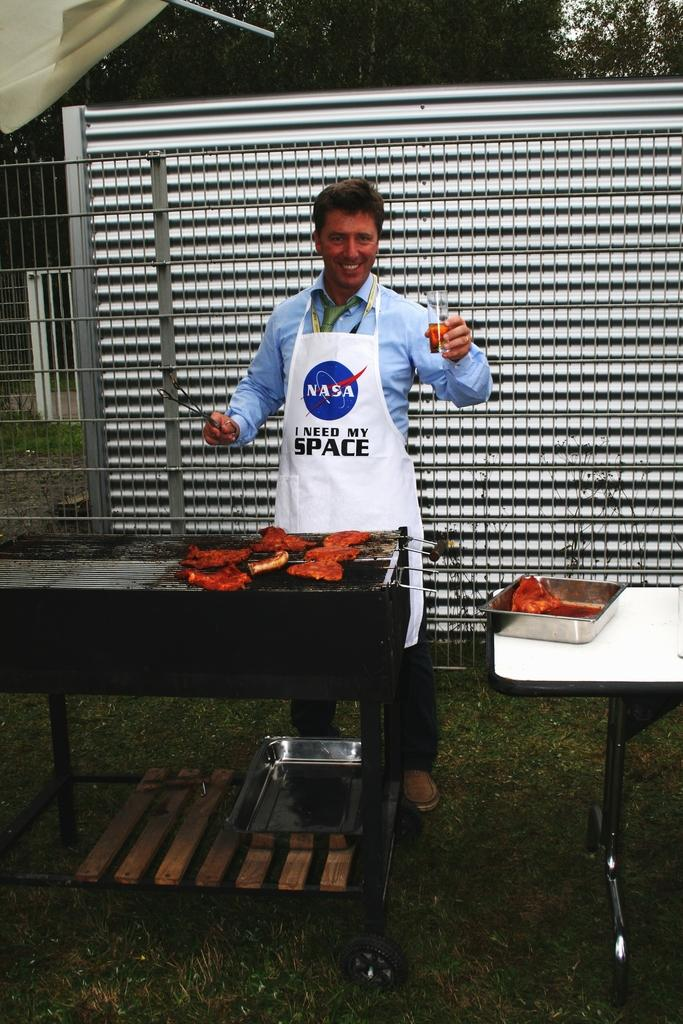<image>
Provide a brief description of the given image. A man wearing an apron that says "NASA I need my Space" 